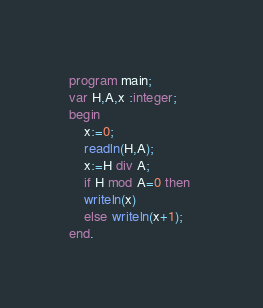<code> <loc_0><loc_0><loc_500><loc_500><_Pascal_>program main;
var H,A,x :integer;
begin
    x:=0;
    readln(H,A);
    x:=H div A;
    if H mod A=0 then 
    writeln(x)
    else writeln(x+1);
end.</code> 